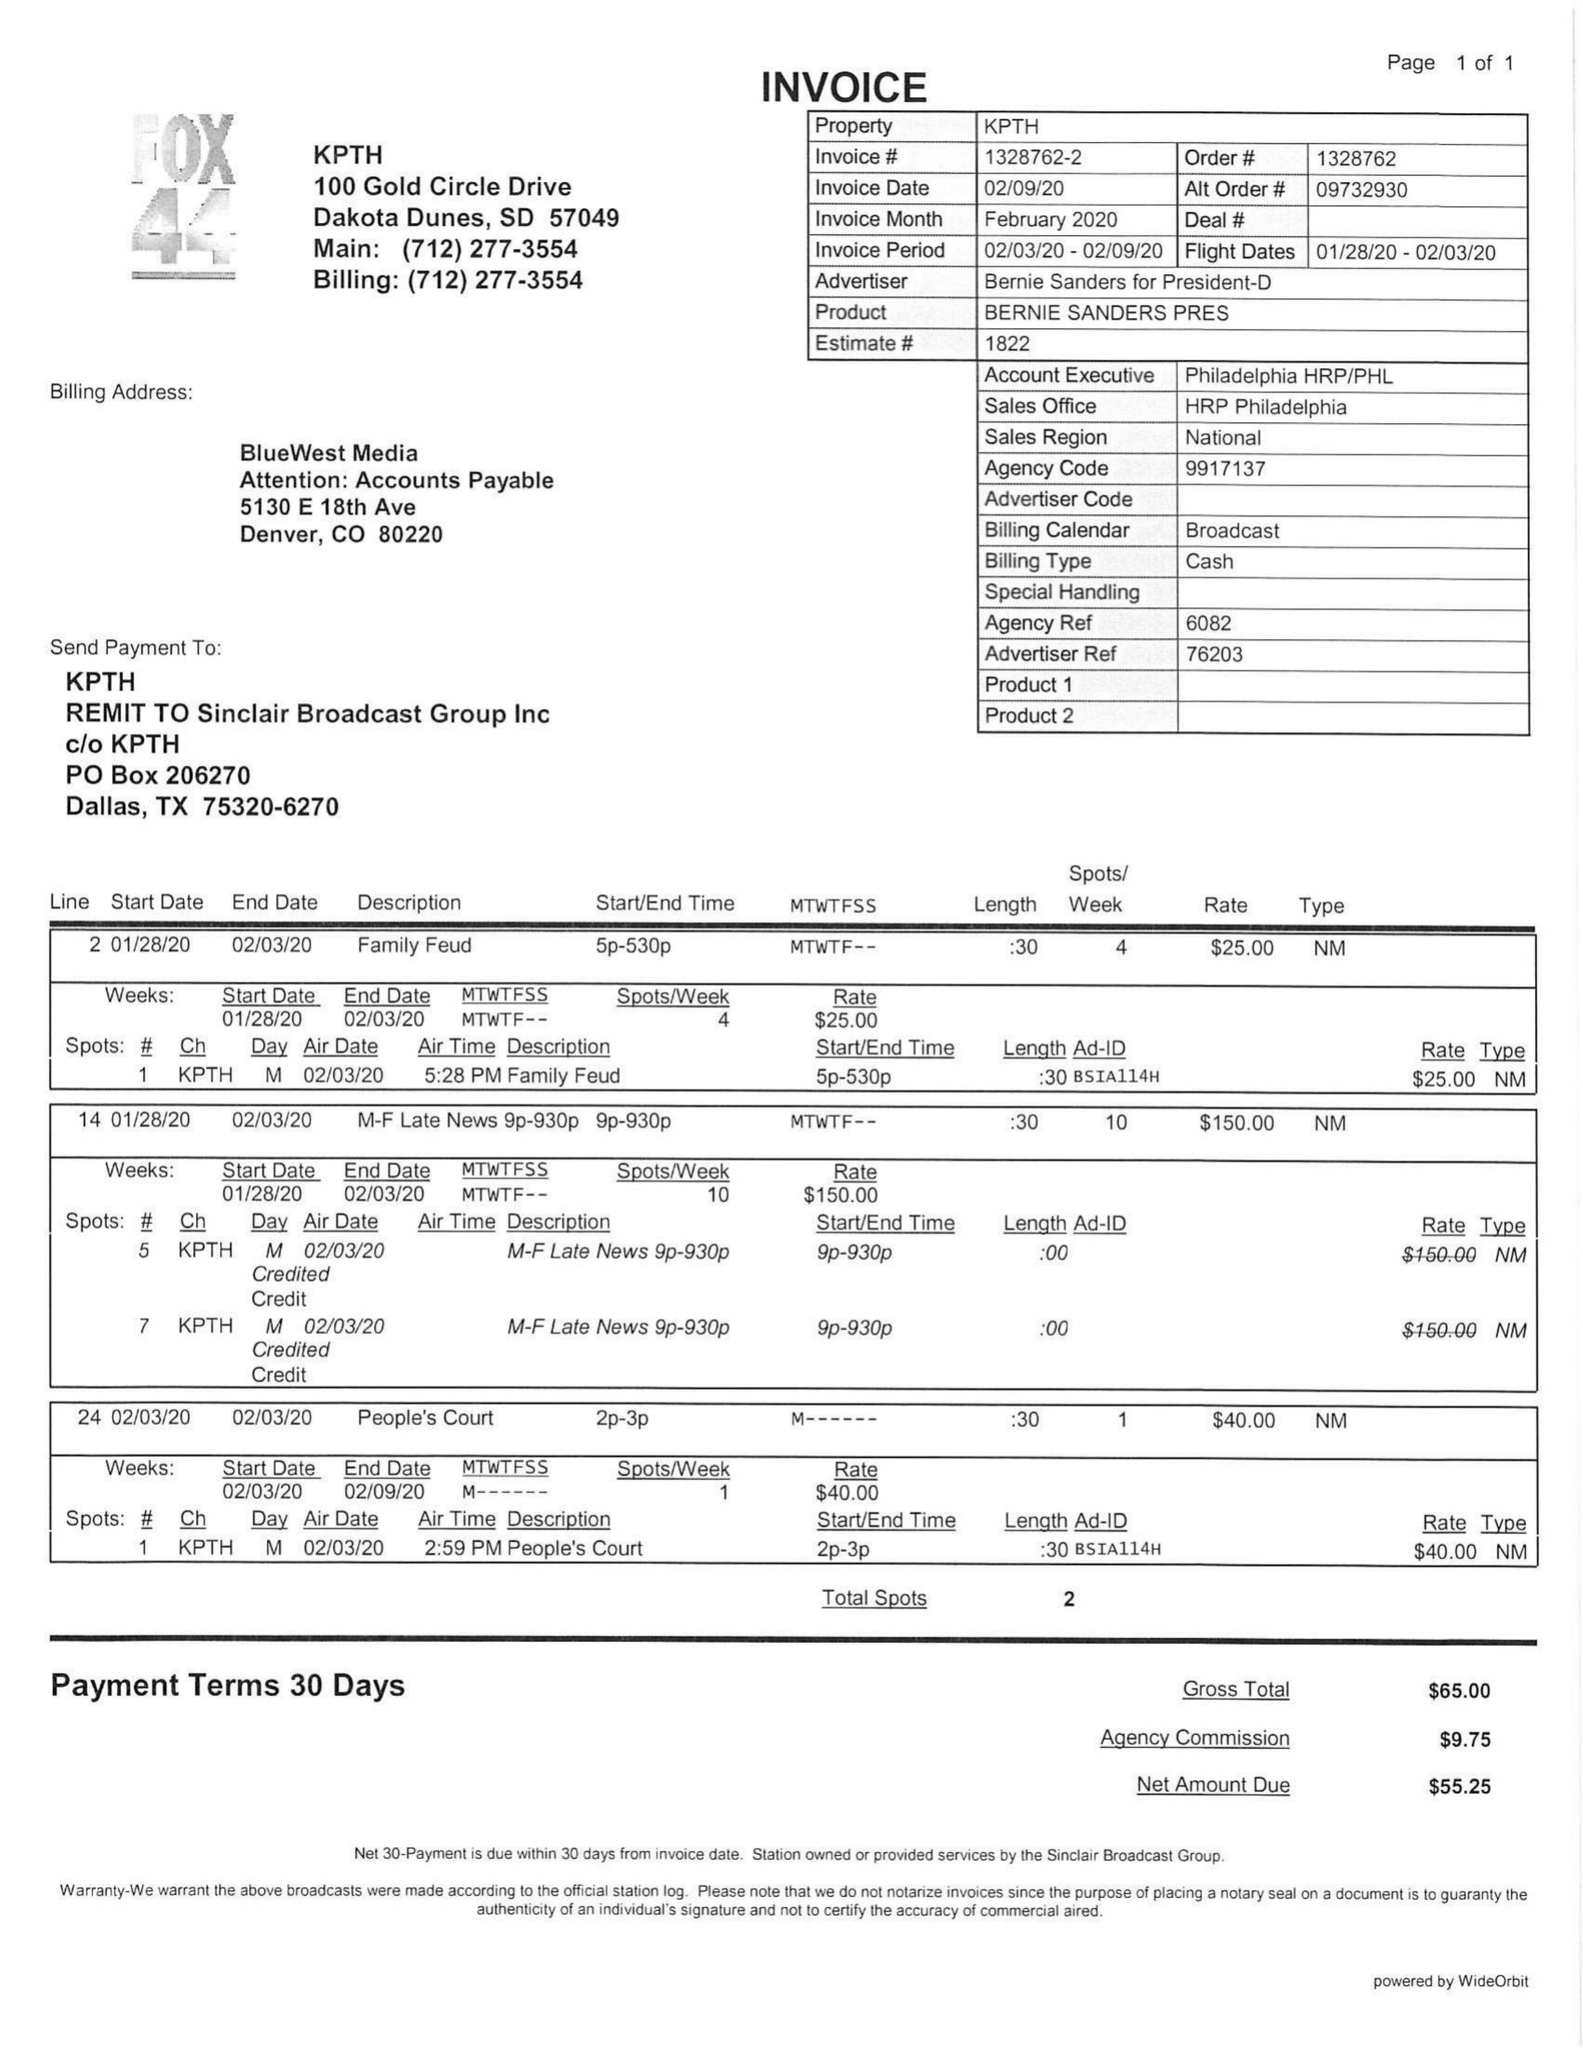What is the value for the advertiser?
Answer the question using a single word or phrase. BERNIE SANDERS FOR PRESIDENT-D 